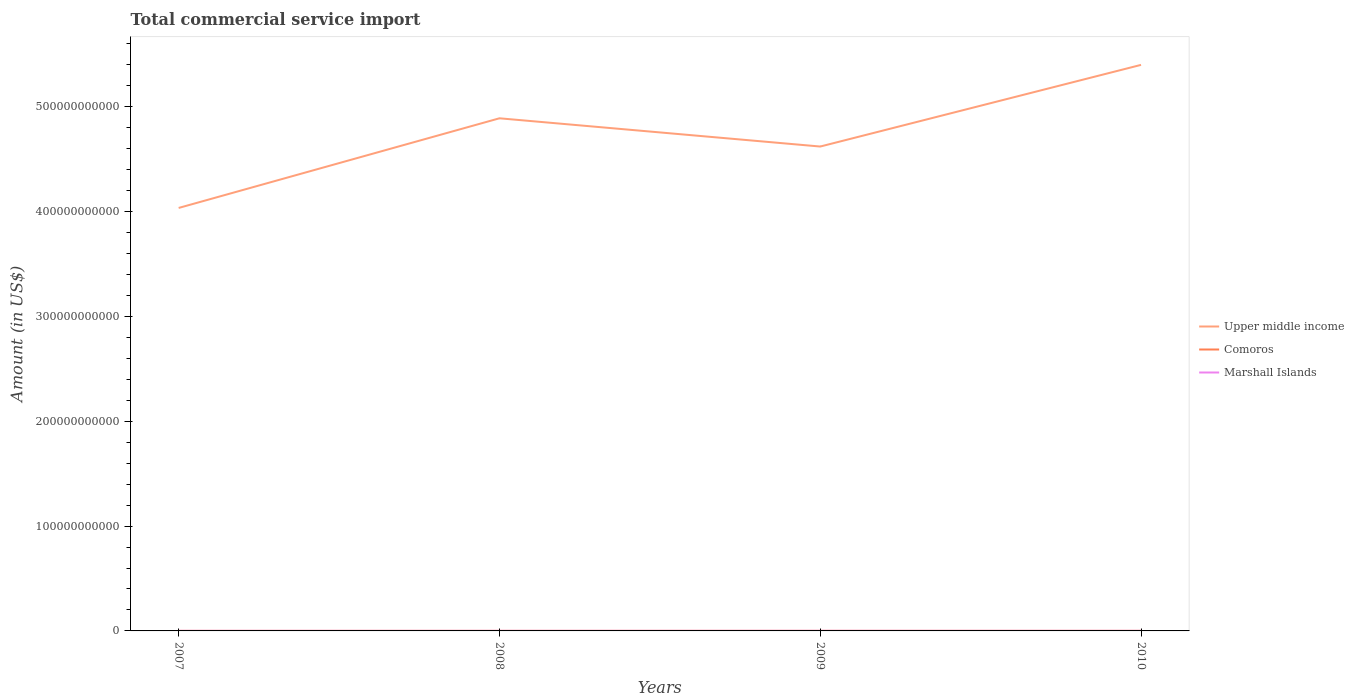How many different coloured lines are there?
Your response must be concise. 3. Is the number of lines equal to the number of legend labels?
Keep it short and to the point. Yes. Across all years, what is the maximum total commercial service import in Comoros?
Your answer should be very brief. 6.23e+07. In which year was the total commercial service import in Marshall Islands maximum?
Your response must be concise. 2008. What is the total total commercial service import in Upper middle income in the graph?
Your answer should be very brief. -5.86e+1. What is the difference between the highest and the second highest total commercial service import in Comoros?
Your response must be concise. 3.06e+07. What is the difference between the highest and the lowest total commercial service import in Comoros?
Ensure brevity in your answer.  2. How many lines are there?
Ensure brevity in your answer.  3. How many years are there in the graph?
Ensure brevity in your answer.  4. What is the difference between two consecutive major ticks on the Y-axis?
Your answer should be compact. 1.00e+11. Does the graph contain grids?
Keep it short and to the point. No. Where does the legend appear in the graph?
Make the answer very short. Center right. How many legend labels are there?
Your answer should be very brief. 3. How are the legend labels stacked?
Your response must be concise. Vertical. What is the title of the graph?
Provide a short and direct response. Total commercial service import. What is the label or title of the X-axis?
Offer a terse response. Years. What is the label or title of the Y-axis?
Give a very brief answer. Amount (in US$). What is the Amount (in US$) in Upper middle income in 2007?
Offer a terse response. 4.04e+11. What is the Amount (in US$) of Comoros in 2007?
Provide a short and direct response. 6.23e+07. What is the Amount (in US$) in Marshall Islands in 2007?
Your answer should be very brief. 5.16e+07. What is the Amount (in US$) of Upper middle income in 2008?
Provide a succinct answer. 4.89e+11. What is the Amount (in US$) in Comoros in 2008?
Offer a terse response. 7.72e+07. What is the Amount (in US$) of Marshall Islands in 2008?
Offer a very short reply. 4.79e+07. What is the Amount (in US$) of Upper middle income in 2009?
Your answer should be very brief. 4.62e+11. What is the Amount (in US$) in Comoros in 2009?
Make the answer very short. 8.35e+07. What is the Amount (in US$) of Marshall Islands in 2009?
Ensure brevity in your answer.  6.24e+07. What is the Amount (in US$) of Upper middle income in 2010?
Your answer should be very brief. 5.40e+11. What is the Amount (in US$) of Comoros in 2010?
Offer a terse response. 9.30e+07. What is the Amount (in US$) in Marshall Islands in 2010?
Your answer should be compact. 5.13e+07. Across all years, what is the maximum Amount (in US$) in Upper middle income?
Ensure brevity in your answer.  5.40e+11. Across all years, what is the maximum Amount (in US$) in Comoros?
Provide a short and direct response. 9.30e+07. Across all years, what is the maximum Amount (in US$) of Marshall Islands?
Your answer should be compact. 6.24e+07. Across all years, what is the minimum Amount (in US$) of Upper middle income?
Offer a terse response. 4.04e+11. Across all years, what is the minimum Amount (in US$) of Comoros?
Offer a very short reply. 6.23e+07. Across all years, what is the minimum Amount (in US$) of Marshall Islands?
Offer a very short reply. 4.79e+07. What is the total Amount (in US$) in Upper middle income in the graph?
Ensure brevity in your answer.  1.89e+12. What is the total Amount (in US$) of Comoros in the graph?
Ensure brevity in your answer.  3.16e+08. What is the total Amount (in US$) in Marshall Islands in the graph?
Offer a very short reply. 2.13e+08. What is the difference between the Amount (in US$) of Upper middle income in 2007 and that in 2008?
Make the answer very short. -8.55e+1. What is the difference between the Amount (in US$) of Comoros in 2007 and that in 2008?
Offer a terse response. -1.49e+07. What is the difference between the Amount (in US$) of Marshall Islands in 2007 and that in 2008?
Ensure brevity in your answer.  3.65e+06. What is the difference between the Amount (in US$) in Upper middle income in 2007 and that in 2009?
Ensure brevity in your answer.  -5.86e+1. What is the difference between the Amount (in US$) in Comoros in 2007 and that in 2009?
Offer a very short reply. -2.12e+07. What is the difference between the Amount (in US$) of Marshall Islands in 2007 and that in 2009?
Your answer should be very brief. -1.08e+07. What is the difference between the Amount (in US$) in Upper middle income in 2007 and that in 2010?
Keep it short and to the point. -1.37e+11. What is the difference between the Amount (in US$) in Comoros in 2007 and that in 2010?
Your answer should be compact. -3.06e+07. What is the difference between the Amount (in US$) in Marshall Islands in 2007 and that in 2010?
Keep it short and to the point. 2.51e+05. What is the difference between the Amount (in US$) of Upper middle income in 2008 and that in 2009?
Your response must be concise. 2.69e+1. What is the difference between the Amount (in US$) of Comoros in 2008 and that in 2009?
Your response must be concise. -6.31e+06. What is the difference between the Amount (in US$) in Marshall Islands in 2008 and that in 2009?
Provide a short and direct response. -1.45e+07. What is the difference between the Amount (in US$) in Upper middle income in 2008 and that in 2010?
Your response must be concise. -5.10e+1. What is the difference between the Amount (in US$) of Comoros in 2008 and that in 2010?
Your answer should be compact. -1.58e+07. What is the difference between the Amount (in US$) in Marshall Islands in 2008 and that in 2010?
Give a very brief answer. -3.40e+06. What is the difference between the Amount (in US$) of Upper middle income in 2009 and that in 2010?
Provide a succinct answer. -7.79e+1. What is the difference between the Amount (in US$) in Comoros in 2009 and that in 2010?
Keep it short and to the point. -9.48e+06. What is the difference between the Amount (in US$) of Marshall Islands in 2009 and that in 2010?
Give a very brief answer. 1.11e+07. What is the difference between the Amount (in US$) of Upper middle income in 2007 and the Amount (in US$) of Comoros in 2008?
Provide a succinct answer. 4.03e+11. What is the difference between the Amount (in US$) of Upper middle income in 2007 and the Amount (in US$) of Marshall Islands in 2008?
Your answer should be compact. 4.04e+11. What is the difference between the Amount (in US$) in Comoros in 2007 and the Amount (in US$) in Marshall Islands in 2008?
Make the answer very short. 1.44e+07. What is the difference between the Amount (in US$) in Upper middle income in 2007 and the Amount (in US$) in Comoros in 2009?
Make the answer very short. 4.03e+11. What is the difference between the Amount (in US$) of Upper middle income in 2007 and the Amount (in US$) of Marshall Islands in 2009?
Provide a succinct answer. 4.03e+11. What is the difference between the Amount (in US$) of Comoros in 2007 and the Amount (in US$) of Marshall Islands in 2009?
Give a very brief answer. -7.07e+04. What is the difference between the Amount (in US$) of Upper middle income in 2007 and the Amount (in US$) of Comoros in 2010?
Keep it short and to the point. 4.03e+11. What is the difference between the Amount (in US$) of Upper middle income in 2007 and the Amount (in US$) of Marshall Islands in 2010?
Make the answer very short. 4.04e+11. What is the difference between the Amount (in US$) of Comoros in 2007 and the Amount (in US$) of Marshall Islands in 2010?
Keep it short and to the point. 1.10e+07. What is the difference between the Amount (in US$) in Upper middle income in 2008 and the Amount (in US$) in Comoros in 2009?
Your response must be concise. 4.89e+11. What is the difference between the Amount (in US$) of Upper middle income in 2008 and the Amount (in US$) of Marshall Islands in 2009?
Provide a succinct answer. 4.89e+11. What is the difference between the Amount (in US$) of Comoros in 2008 and the Amount (in US$) of Marshall Islands in 2009?
Provide a succinct answer. 1.48e+07. What is the difference between the Amount (in US$) of Upper middle income in 2008 and the Amount (in US$) of Comoros in 2010?
Your answer should be compact. 4.89e+11. What is the difference between the Amount (in US$) of Upper middle income in 2008 and the Amount (in US$) of Marshall Islands in 2010?
Give a very brief answer. 4.89e+11. What is the difference between the Amount (in US$) in Comoros in 2008 and the Amount (in US$) in Marshall Islands in 2010?
Give a very brief answer. 2.59e+07. What is the difference between the Amount (in US$) in Upper middle income in 2009 and the Amount (in US$) in Comoros in 2010?
Provide a succinct answer. 4.62e+11. What is the difference between the Amount (in US$) of Upper middle income in 2009 and the Amount (in US$) of Marshall Islands in 2010?
Make the answer very short. 4.62e+11. What is the difference between the Amount (in US$) in Comoros in 2009 and the Amount (in US$) in Marshall Islands in 2010?
Provide a succinct answer. 3.22e+07. What is the average Amount (in US$) in Upper middle income per year?
Offer a very short reply. 4.74e+11. What is the average Amount (in US$) of Comoros per year?
Your answer should be compact. 7.90e+07. What is the average Amount (in US$) of Marshall Islands per year?
Offer a terse response. 5.33e+07. In the year 2007, what is the difference between the Amount (in US$) of Upper middle income and Amount (in US$) of Comoros?
Provide a short and direct response. 4.03e+11. In the year 2007, what is the difference between the Amount (in US$) of Upper middle income and Amount (in US$) of Marshall Islands?
Provide a short and direct response. 4.04e+11. In the year 2007, what is the difference between the Amount (in US$) of Comoros and Amount (in US$) of Marshall Islands?
Keep it short and to the point. 1.07e+07. In the year 2008, what is the difference between the Amount (in US$) of Upper middle income and Amount (in US$) of Comoros?
Offer a terse response. 4.89e+11. In the year 2008, what is the difference between the Amount (in US$) of Upper middle income and Amount (in US$) of Marshall Islands?
Offer a very short reply. 4.89e+11. In the year 2008, what is the difference between the Amount (in US$) in Comoros and Amount (in US$) in Marshall Islands?
Provide a succinct answer. 2.93e+07. In the year 2009, what is the difference between the Amount (in US$) of Upper middle income and Amount (in US$) of Comoros?
Keep it short and to the point. 4.62e+11. In the year 2009, what is the difference between the Amount (in US$) in Upper middle income and Amount (in US$) in Marshall Islands?
Offer a very short reply. 4.62e+11. In the year 2009, what is the difference between the Amount (in US$) of Comoros and Amount (in US$) of Marshall Islands?
Keep it short and to the point. 2.11e+07. In the year 2010, what is the difference between the Amount (in US$) of Upper middle income and Amount (in US$) of Comoros?
Offer a terse response. 5.40e+11. In the year 2010, what is the difference between the Amount (in US$) in Upper middle income and Amount (in US$) in Marshall Islands?
Offer a terse response. 5.40e+11. In the year 2010, what is the difference between the Amount (in US$) in Comoros and Amount (in US$) in Marshall Islands?
Your response must be concise. 4.16e+07. What is the ratio of the Amount (in US$) of Upper middle income in 2007 to that in 2008?
Make the answer very short. 0.83. What is the ratio of the Amount (in US$) of Comoros in 2007 to that in 2008?
Make the answer very short. 0.81. What is the ratio of the Amount (in US$) in Marshall Islands in 2007 to that in 2008?
Ensure brevity in your answer.  1.08. What is the ratio of the Amount (in US$) of Upper middle income in 2007 to that in 2009?
Give a very brief answer. 0.87. What is the ratio of the Amount (in US$) in Comoros in 2007 to that in 2009?
Offer a terse response. 0.75. What is the ratio of the Amount (in US$) in Marshall Islands in 2007 to that in 2009?
Make the answer very short. 0.83. What is the ratio of the Amount (in US$) of Upper middle income in 2007 to that in 2010?
Give a very brief answer. 0.75. What is the ratio of the Amount (in US$) in Comoros in 2007 to that in 2010?
Your response must be concise. 0.67. What is the ratio of the Amount (in US$) of Upper middle income in 2008 to that in 2009?
Provide a short and direct response. 1.06. What is the ratio of the Amount (in US$) in Comoros in 2008 to that in 2009?
Give a very brief answer. 0.92. What is the ratio of the Amount (in US$) of Marshall Islands in 2008 to that in 2009?
Offer a very short reply. 0.77. What is the ratio of the Amount (in US$) in Upper middle income in 2008 to that in 2010?
Offer a terse response. 0.91. What is the ratio of the Amount (in US$) of Comoros in 2008 to that in 2010?
Offer a very short reply. 0.83. What is the ratio of the Amount (in US$) of Marshall Islands in 2008 to that in 2010?
Keep it short and to the point. 0.93. What is the ratio of the Amount (in US$) in Upper middle income in 2009 to that in 2010?
Offer a very short reply. 0.86. What is the ratio of the Amount (in US$) in Comoros in 2009 to that in 2010?
Your answer should be very brief. 0.9. What is the ratio of the Amount (in US$) in Marshall Islands in 2009 to that in 2010?
Ensure brevity in your answer.  1.22. What is the difference between the highest and the second highest Amount (in US$) in Upper middle income?
Ensure brevity in your answer.  5.10e+1. What is the difference between the highest and the second highest Amount (in US$) in Comoros?
Your response must be concise. 9.48e+06. What is the difference between the highest and the second highest Amount (in US$) of Marshall Islands?
Keep it short and to the point. 1.08e+07. What is the difference between the highest and the lowest Amount (in US$) of Upper middle income?
Keep it short and to the point. 1.37e+11. What is the difference between the highest and the lowest Amount (in US$) of Comoros?
Provide a short and direct response. 3.06e+07. What is the difference between the highest and the lowest Amount (in US$) of Marshall Islands?
Keep it short and to the point. 1.45e+07. 